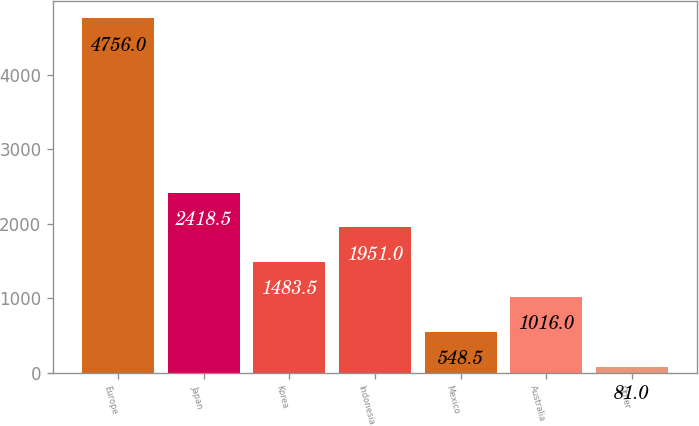<chart> <loc_0><loc_0><loc_500><loc_500><bar_chart><fcel>Europe<fcel>Japan<fcel>Korea<fcel>Indonesia<fcel>Mexico<fcel>Australia<fcel>Other<nl><fcel>4756<fcel>2418.5<fcel>1483.5<fcel>1951<fcel>548.5<fcel>1016<fcel>81<nl></chart> 